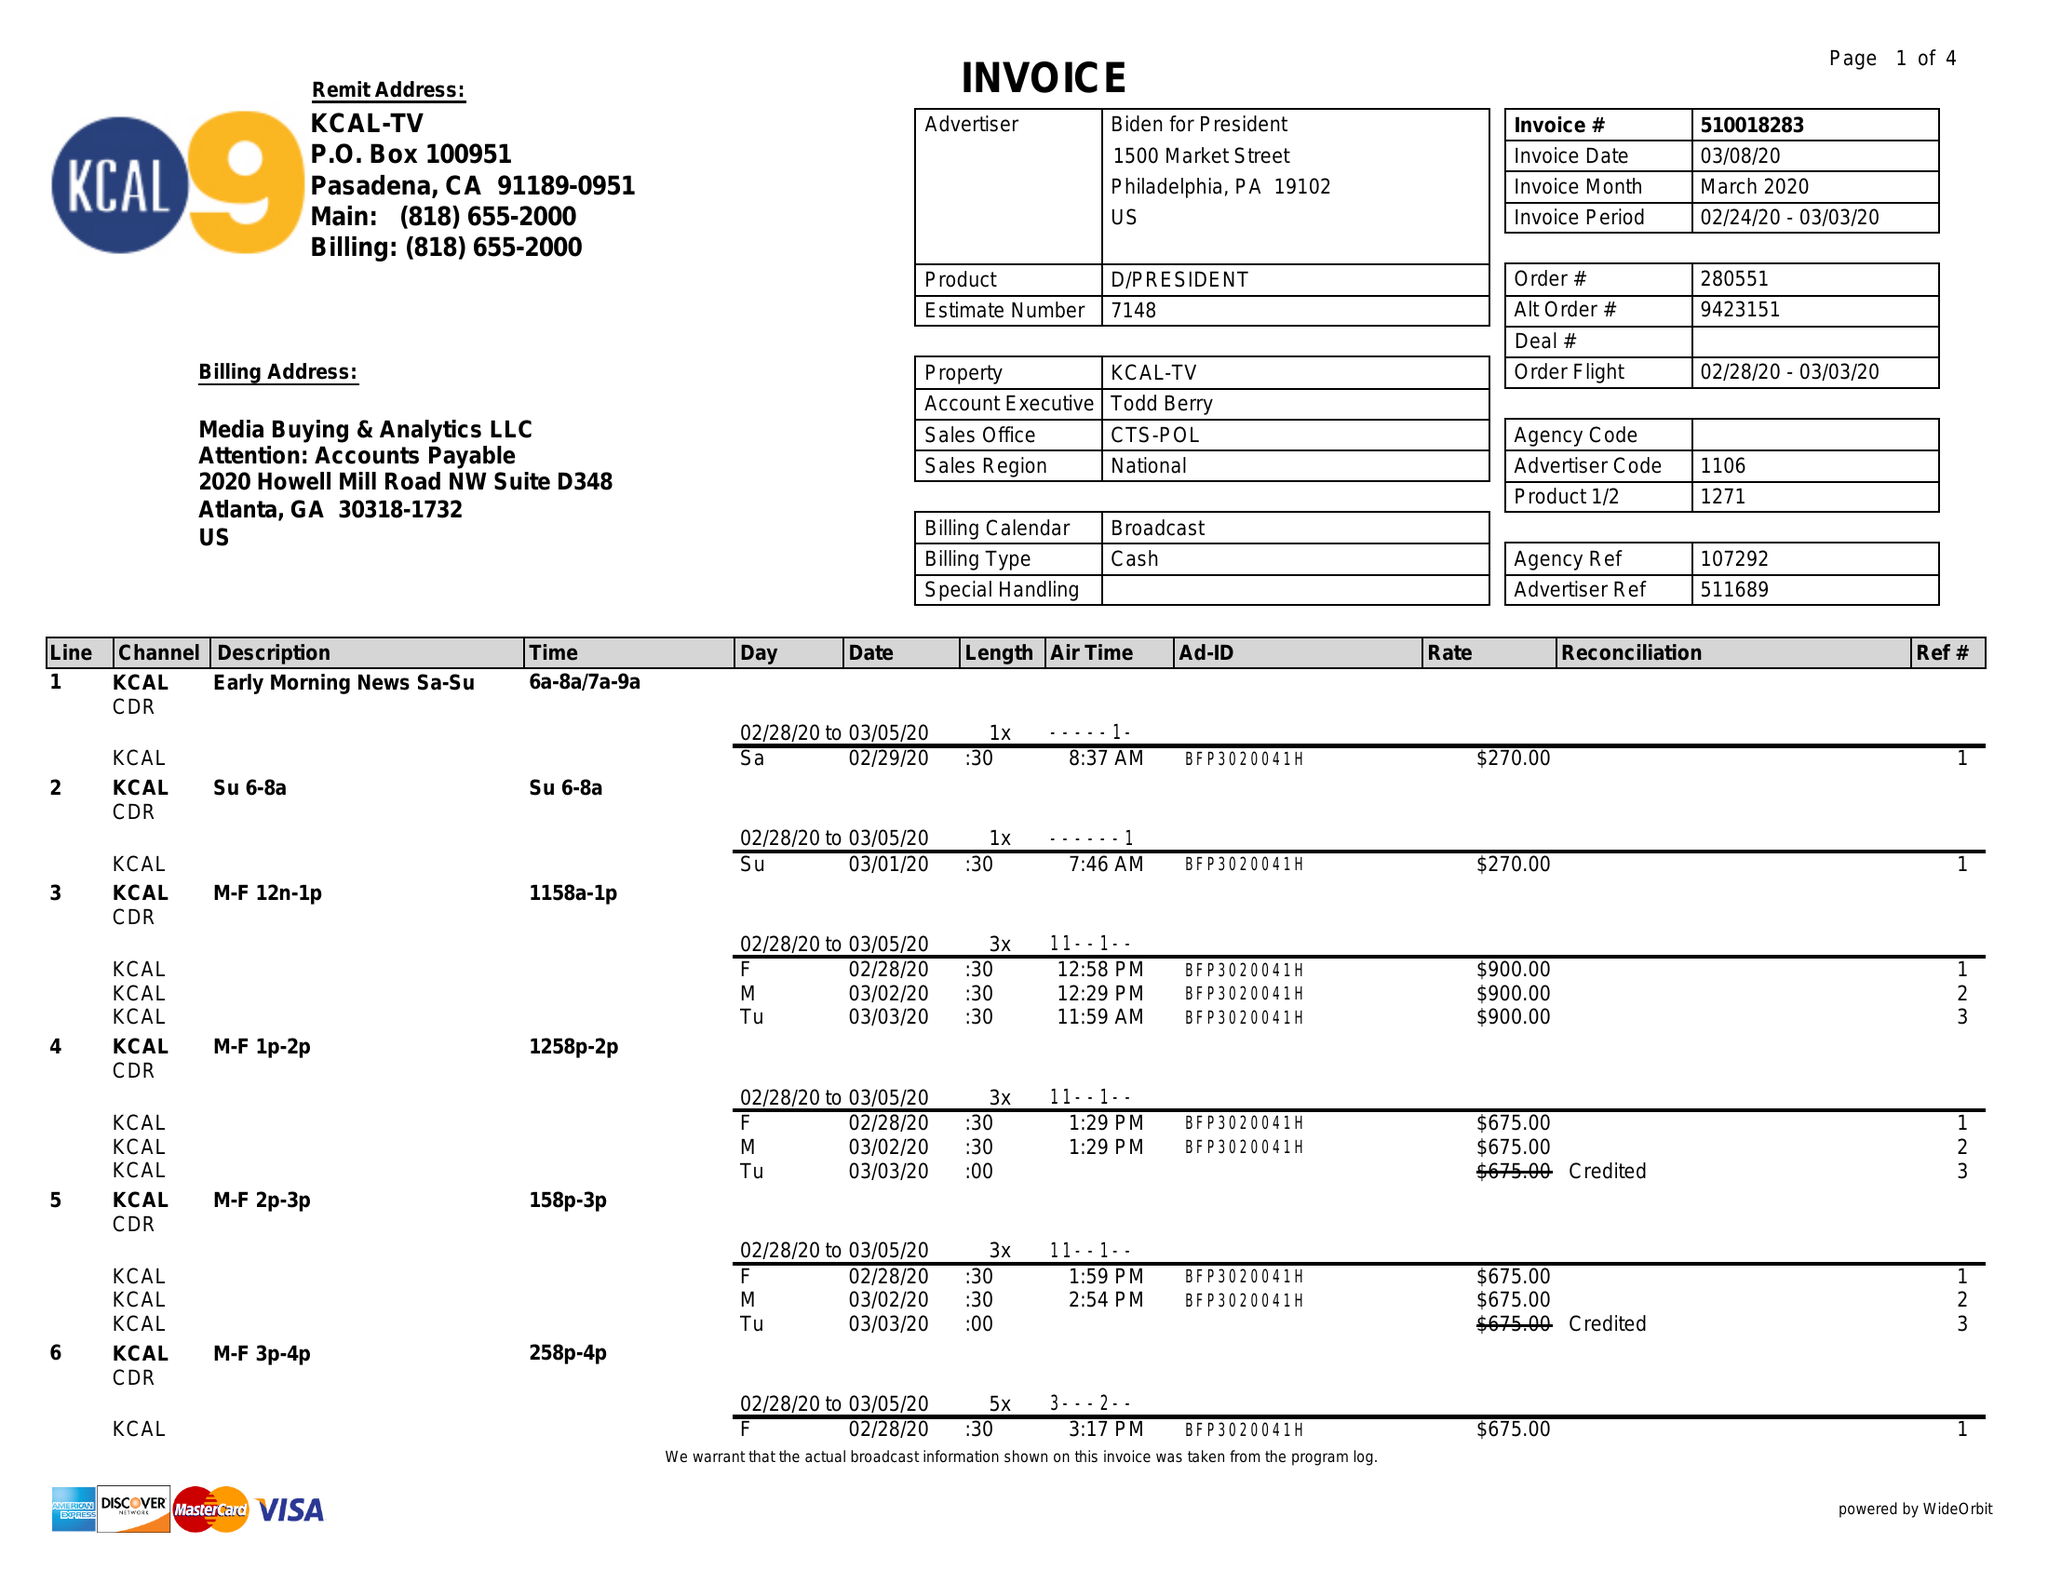What is the value for the flight_from?
Answer the question using a single word or phrase. 02/24/20 